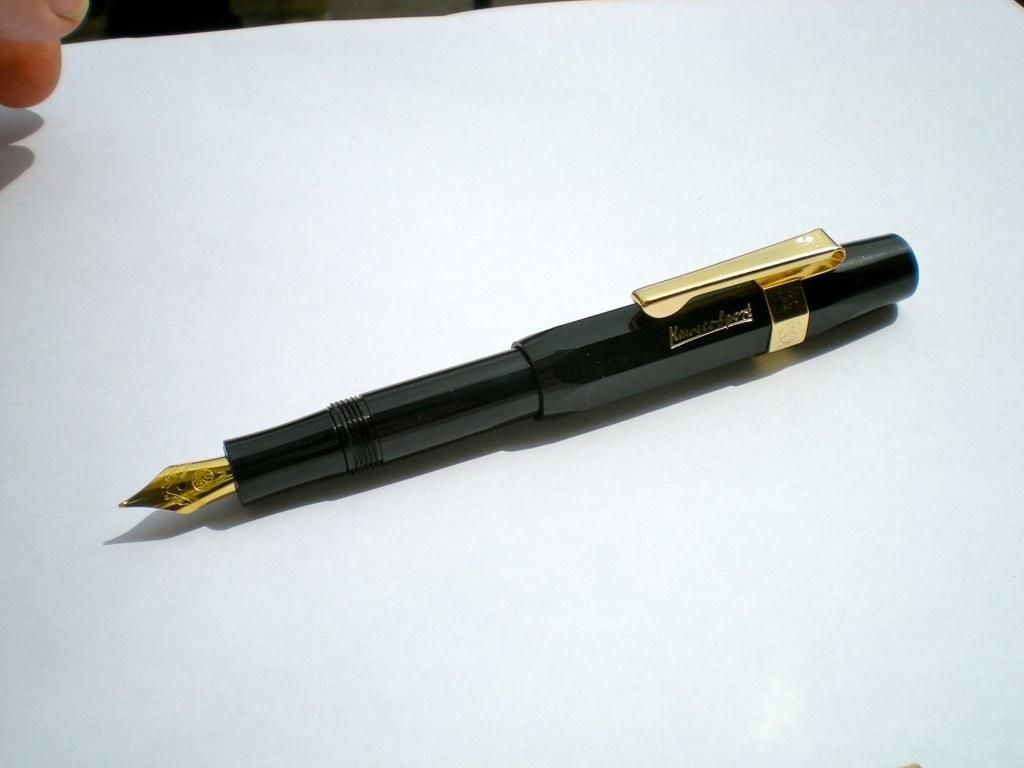What object is placed on the paper in the image? There is a pen placed on a paper in the image. What might the fingers be doing in the image? The fingers might be holding or touching the pen or paper in the image. Can you describe the position of the pen in relation to the paper? The pen is placed on the paper in the image. What type of insurance is being discussed in the image? There is no discussion of insurance in the image; it features a pen placed on a paper with fingers visible in the top left corner. 